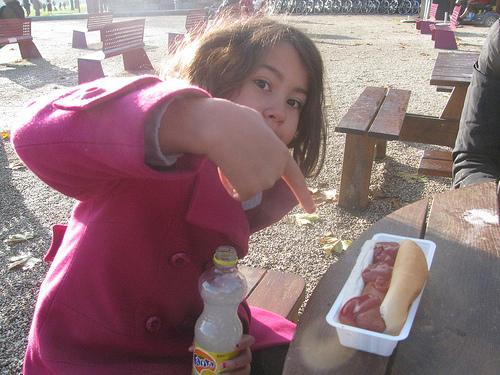Write a concise description of the image focusing on the girl's appearance. The image features a girl with brown hair and eyes wearing a pink pea coat adorned with pink plastic buttons, and pointing her pink-painted fingernail. Explain what the girl's facial features look like in the image. The girl's face has brown eyes, a nose, and an eyebrow, with her pointer finger near her mouth, and her pink-painted fingernails visible. Comment on the food items present in the image and their details. The image includes a hotdog with a generous amount of ketchup in a white container, a bottle of Fanta with an orange and blue label, and a lemonade in the girl's hand. Identify the colors and objects present in the image. The image features a pink coat, pink buttons, pink fingernails, red benches, a hotdog with ketchup, a bottle of Fanta, a wooden table, and green leaves on the ground. Write a description of the girl's hand gestures and accessories. The girl is pointing her pink painted fingernail towards a hotdog in her left hand, while holding a bottle of Fanta and a lemonade in her right hand. Provide a brief overview of the image including the primary objects and actions. A girl in a pink coat is pointing at a hotdog with ketchup while holding a bottle of Fanta, with park benches, a picnic table, and bicycles in the background. Compose a sentence describing the girl and her interaction with the food items in the picture. A brown-haired girl wearing a pink pea coat points at a ketchup-covered hotdog while holding a bottle of Fanta in her other hand. Mention the objects found in the park setting of the image. In the park setting, there are red benches, a wooden picnic table, a row of bicycles, and leaves scattered on the ground. Briefly summarize the scene captured in the image. The image captures a girl in a pink coat, pointing at hotdog with ketchup and holding beverages, amidst park setting elements such as benches, a table, and bicycles. Describe the appearance of the benches in the picture. There are red park benches and a dark wooden bench, with a brown seat, scattered across the park setting in the image. 